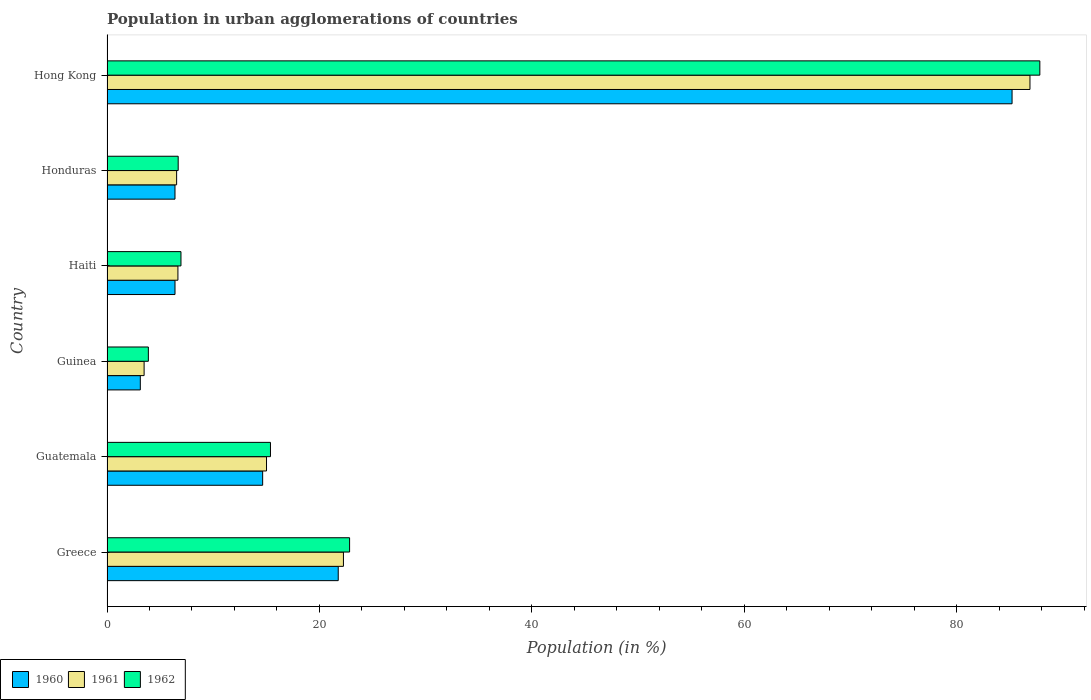How many different coloured bars are there?
Make the answer very short. 3. How many bars are there on the 1st tick from the top?
Give a very brief answer. 3. How many bars are there on the 6th tick from the bottom?
Offer a very short reply. 3. What is the label of the 3rd group of bars from the top?
Ensure brevity in your answer.  Haiti. In how many cases, is the number of bars for a given country not equal to the number of legend labels?
Your answer should be compact. 0. What is the percentage of population in urban agglomerations in 1960 in Guinea?
Make the answer very short. 3.14. Across all countries, what is the maximum percentage of population in urban agglomerations in 1960?
Make the answer very short. 85.2. Across all countries, what is the minimum percentage of population in urban agglomerations in 1962?
Your answer should be compact. 3.89. In which country was the percentage of population in urban agglomerations in 1962 maximum?
Your response must be concise. Hong Kong. In which country was the percentage of population in urban agglomerations in 1960 minimum?
Provide a succinct answer. Guinea. What is the total percentage of population in urban agglomerations in 1961 in the graph?
Provide a short and direct response. 140.89. What is the difference between the percentage of population in urban agglomerations in 1960 in Greece and that in Hong Kong?
Offer a very short reply. -63.44. What is the difference between the percentage of population in urban agglomerations in 1961 in Honduras and the percentage of population in urban agglomerations in 1962 in Guinea?
Provide a succinct answer. 2.66. What is the average percentage of population in urban agglomerations in 1960 per country?
Your response must be concise. 22.93. What is the difference between the percentage of population in urban agglomerations in 1960 and percentage of population in urban agglomerations in 1962 in Haiti?
Your answer should be very brief. -0.56. What is the ratio of the percentage of population in urban agglomerations in 1960 in Guinea to that in Honduras?
Make the answer very short. 0.49. Is the percentage of population in urban agglomerations in 1960 in Guatemala less than that in Honduras?
Your response must be concise. No. Is the difference between the percentage of population in urban agglomerations in 1960 in Guinea and Haiti greater than the difference between the percentage of population in urban agglomerations in 1962 in Guinea and Haiti?
Provide a succinct answer. No. What is the difference between the highest and the second highest percentage of population in urban agglomerations in 1962?
Offer a terse response. 64.98. What is the difference between the highest and the lowest percentage of population in urban agglomerations in 1960?
Keep it short and to the point. 82.07. Is the sum of the percentage of population in urban agglomerations in 1962 in Greece and Guatemala greater than the maximum percentage of population in urban agglomerations in 1961 across all countries?
Ensure brevity in your answer.  No. What does the 1st bar from the top in Hong Kong represents?
Give a very brief answer. 1962. What does the 1st bar from the bottom in Guatemala represents?
Your response must be concise. 1960. How many bars are there?
Your answer should be very brief. 18. Are all the bars in the graph horizontal?
Make the answer very short. Yes. What is the difference between two consecutive major ticks on the X-axis?
Offer a terse response. 20. Does the graph contain any zero values?
Give a very brief answer. No. Does the graph contain grids?
Your answer should be compact. No. Where does the legend appear in the graph?
Keep it short and to the point. Bottom left. How many legend labels are there?
Make the answer very short. 3. How are the legend labels stacked?
Ensure brevity in your answer.  Horizontal. What is the title of the graph?
Your answer should be compact. Population in urban agglomerations of countries. Does "1991" appear as one of the legend labels in the graph?
Make the answer very short. No. What is the label or title of the Y-axis?
Your answer should be compact. Country. What is the Population (in %) of 1960 in Greece?
Your answer should be compact. 21.77. What is the Population (in %) in 1961 in Greece?
Keep it short and to the point. 22.26. What is the Population (in %) of 1962 in Greece?
Ensure brevity in your answer.  22.84. What is the Population (in %) of 1960 in Guatemala?
Make the answer very short. 14.65. What is the Population (in %) of 1961 in Guatemala?
Provide a short and direct response. 15.02. What is the Population (in %) of 1962 in Guatemala?
Keep it short and to the point. 15.39. What is the Population (in %) of 1960 in Guinea?
Provide a short and direct response. 3.14. What is the Population (in %) of 1961 in Guinea?
Offer a very short reply. 3.49. What is the Population (in %) of 1962 in Guinea?
Ensure brevity in your answer.  3.89. What is the Population (in %) of 1960 in Haiti?
Give a very brief answer. 6.4. What is the Population (in %) in 1961 in Haiti?
Give a very brief answer. 6.68. What is the Population (in %) in 1962 in Haiti?
Your response must be concise. 6.96. What is the Population (in %) in 1960 in Honduras?
Give a very brief answer. 6.4. What is the Population (in %) of 1961 in Honduras?
Make the answer very short. 6.55. What is the Population (in %) in 1962 in Honduras?
Your answer should be compact. 6.7. What is the Population (in %) in 1960 in Hong Kong?
Provide a short and direct response. 85.2. What is the Population (in %) in 1961 in Hong Kong?
Your answer should be compact. 86.89. What is the Population (in %) in 1962 in Hong Kong?
Give a very brief answer. 87.82. Across all countries, what is the maximum Population (in %) of 1960?
Provide a succinct answer. 85.2. Across all countries, what is the maximum Population (in %) of 1961?
Offer a terse response. 86.89. Across all countries, what is the maximum Population (in %) of 1962?
Provide a short and direct response. 87.82. Across all countries, what is the minimum Population (in %) of 1960?
Offer a terse response. 3.14. Across all countries, what is the minimum Population (in %) of 1961?
Keep it short and to the point. 3.49. Across all countries, what is the minimum Population (in %) of 1962?
Your answer should be compact. 3.89. What is the total Population (in %) in 1960 in the graph?
Provide a short and direct response. 137.56. What is the total Population (in %) of 1961 in the graph?
Your answer should be very brief. 140.89. What is the total Population (in %) of 1962 in the graph?
Your answer should be compact. 143.6. What is the difference between the Population (in %) in 1960 in Greece and that in Guatemala?
Keep it short and to the point. 7.12. What is the difference between the Population (in %) of 1961 in Greece and that in Guatemala?
Your response must be concise. 7.24. What is the difference between the Population (in %) in 1962 in Greece and that in Guatemala?
Offer a very short reply. 7.45. What is the difference between the Population (in %) of 1960 in Greece and that in Guinea?
Give a very brief answer. 18.63. What is the difference between the Population (in %) in 1961 in Greece and that in Guinea?
Your response must be concise. 18.77. What is the difference between the Population (in %) of 1962 in Greece and that in Guinea?
Ensure brevity in your answer.  18.94. What is the difference between the Population (in %) of 1960 in Greece and that in Haiti?
Give a very brief answer. 15.37. What is the difference between the Population (in %) of 1961 in Greece and that in Haiti?
Keep it short and to the point. 15.58. What is the difference between the Population (in %) of 1962 in Greece and that in Haiti?
Offer a very short reply. 15.87. What is the difference between the Population (in %) in 1960 in Greece and that in Honduras?
Your answer should be very brief. 15.37. What is the difference between the Population (in %) of 1961 in Greece and that in Honduras?
Your answer should be very brief. 15.7. What is the difference between the Population (in %) in 1962 in Greece and that in Honduras?
Offer a very short reply. 16.14. What is the difference between the Population (in %) in 1960 in Greece and that in Hong Kong?
Make the answer very short. -63.44. What is the difference between the Population (in %) in 1961 in Greece and that in Hong Kong?
Keep it short and to the point. -64.63. What is the difference between the Population (in %) in 1962 in Greece and that in Hong Kong?
Ensure brevity in your answer.  -64.98. What is the difference between the Population (in %) in 1960 in Guatemala and that in Guinea?
Offer a very short reply. 11.52. What is the difference between the Population (in %) in 1961 in Guatemala and that in Guinea?
Ensure brevity in your answer.  11.52. What is the difference between the Population (in %) of 1962 in Guatemala and that in Guinea?
Your answer should be compact. 11.49. What is the difference between the Population (in %) of 1960 in Guatemala and that in Haiti?
Offer a very short reply. 8.25. What is the difference between the Population (in %) of 1961 in Guatemala and that in Haiti?
Offer a terse response. 8.34. What is the difference between the Population (in %) of 1962 in Guatemala and that in Haiti?
Ensure brevity in your answer.  8.43. What is the difference between the Population (in %) in 1960 in Guatemala and that in Honduras?
Keep it short and to the point. 8.25. What is the difference between the Population (in %) in 1961 in Guatemala and that in Honduras?
Your answer should be very brief. 8.46. What is the difference between the Population (in %) in 1962 in Guatemala and that in Honduras?
Give a very brief answer. 8.69. What is the difference between the Population (in %) in 1960 in Guatemala and that in Hong Kong?
Ensure brevity in your answer.  -70.55. What is the difference between the Population (in %) of 1961 in Guatemala and that in Hong Kong?
Keep it short and to the point. -71.87. What is the difference between the Population (in %) of 1962 in Guatemala and that in Hong Kong?
Make the answer very short. -72.43. What is the difference between the Population (in %) in 1960 in Guinea and that in Haiti?
Make the answer very short. -3.27. What is the difference between the Population (in %) of 1961 in Guinea and that in Haiti?
Offer a very short reply. -3.18. What is the difference between the Population (in %) in 1962 in Guinea and that in Haiti?
Give a very brief answer. -3.07. What is the difference between the Population (in %) of 1960 in Guinea and that in Honduras?
Your answer should be very brief. -3.27. What is the difference between the Population (in %) of 1961 in Guinea and that in Honduras?
Your response must be concise. -3.06. What is the difference between the Population (in %) in 1962 in Guinea and that in Honduras?
Give a very brief answer. -2.81. What is the difference between the Population (in %) of 1960 in Guinea and that in Hong Kong?
Provide a short and direct response. -82.07. What is the difference between the Population (in %) in 1961 in Guinea and that in Hong Kong?
Your answer should be very brief. -83.4. What is the difference between the Population (in %) in 1962 in Guinea and that in Hong Kong?
Provide a short and direct response. -83.93. What is the difference between the Population (in %) of 1960 in Haiti and that in Honduras?
Ensure brevity in your answer.  0. What is the difference between the Population (in %) in 1961 in Haiti and that in Honduras?
Provide a short and direct response. 0.12. What is the difference between the Population (in %) of 1962 in Haiti and that in Honduras?
Provide a short and direct response. 0.26. What is the difference between the Population (in %) in 1960 in Haiti and that in Hong Kong?
Make the answer very short. -78.8. What is the difference between the Population (in %) in 1961 in Haiti and that in Hong Kong?
Ensure brevity in your answer.  -80.21. What is the difference between the Population (in %) of 1962 in Haiti and that in Hong Kong?
Provide a succinct answer. -80.86. What is the difference between the Population (in %) of 1960 in Honduras and that in Hong Kong?
Your answer should be very brief. -78.8. What is the difference between the Population (in %) of 1961 in Honduras and that in Hong Kong?
Your answer should be compact. -80.34. What is the difference between the Population (in %) in 1962 in Honduras and that in Hong Kong?
Your answer should be very brief. -81.12. What is the difference between the Population (in %) of 1960 in Greece and the Population (in %) of 1961 in Guatemala?
Offer a very short reply. 6.75. What is the difference between the Population (in %) in 1960 in Greece and the Population (in %) in 1962 in Guatemala?
Your answer should be very brief. 6.38. What is the difference between the Population (in %) of 1961 in Greece and the Population (in %) of 1962 in Guatemala?
Make the answer very short. 6.87. What is the difference between the Population (in %) of 1960 in Greece and the Population (in %) of 1961 in Guinea?
Give a very brief answer. 18.27. What is the difference between the Population (in %) in 1960 in Greece and the Population (in %) in 1962 in Guinea?
Provide a succinct answer. 17.87. What is the difference between the Population (in %) of 1961 in Greece and the Population (in %) of 1962 in Guinea?
Your answer should be very brief. 18.37. What is the difference between the Population (in %) of 1960 in Greece and the Population (in %) of 1961 in Haiti?
Make the answer very short. 15.09. What is the difference between the Population (in %) in 1960 in Greece and the Population (in %) in 1962 in Haiti?
Keep it short and to the point. 14.81. What is the difference between the Population (in %) in 1961 in Greece and the Population (in %) in 1962 in Haiti?
Provide a succinct answer. 15.3. What is the difference between the Population (in %) of 1960 in Greece and the Population (in %) of 1961 in Honduras?
Your answer should be very brief. 15.21. What is the difference between the Population (in %) in 1960 in Greece and the Population (in %) in 1962 in Honduras?
Your answer should be compact. 15.07. What is the difference between the Population (in %) of 1961 in Greece and the Population (in %) of 1962 in Honduras?
Provide a succinct answer. 15.56. What is the difference between the Population (in %) of 1960 in Greece and the Population (in %) of 1961 in Hong Kong?
Provide a succinct answer. -65.12. What is the difference between the Population (in %) in 1960 in Greece and the Population (in %) in 1962 in Hong Kong?
Make the answer very short. -66.05. What is the difference between the Population (in %) in 1961 in Greece and the Population (in %) in 1962 in Hong Kong?
Your answer should be very brief. -65.56. What is the difference between the Population (in %) of 1960 in Guatemala and the Population (in %) of 1961 in Guinea?
Provide a succinct answer. 11.16. What is the difference between the Population (in %) in 1960 in Guatemala and the Population (in %) in 1962 in Guinea?
Make the answer very short. 10.76. What is the difference between the Population (in %) of 1961 in Guatemala and the Population (in %) of 1962 in Guinea?
Offer a very short reply. 11.12. What is the difference between the Population (in %) of 1960 in Guatemala and the Population (in %) of 1961 in Haiti?
Give a very brief answer. 7.98. What is the difference between the Population (in %) in 1960 in Guatemala and the Population (in %) in 1962 in Haiti?
Provide a short and direct response. 7.69. What is the difference between the Population (in %) in 1961 in Guatemala and the Population (in %) in 1962 in Haiti?
Give a very brief answer. 8.05. What is the difference between the Population (in %) of 1960 in Guatemala and the Population (in %) of 1961 in Honduras?
Provide a short and direct response. 8.1. What is the difference between the Population (in %) in 1960 in Guatemala and the Population (in %) in 1962 in Honduras?
Ensure brevity in your answer.  7.95. What is the difference between the Population (in %) in 1961 in Guatemala and the Population (in %) in 1962 in Honduras?
Offer a very short reply. 8.32. What is the difference between the Population (in %) of 1960 in Guatemala and the Population (in %) of 1961 in Hong Kong?
Ensure brevity in your answer.  -72.24. What is the difference between the Population (in %) of 1960 in Guatemala and the Population (in %) of 1962 in Hong Kong?
Keep it short and to the point. -73.17. What is the difference between the Population (in %) of 1961 in Guatemala and the Population (in %) of 1962 in Hong Kong?
Your answer should be compact. -72.8. What is the difference between the Population (in %) of 1960 in Guinea and the Population (in %) of 1961 in Haiti?
Provide a short and direct response. -3.54. What is the difference between the Population (in %) of 1960 in Guinea and the Population (in %) of 1962 in Haiti?
Provide a succinct answer. -3.83. What is the difference between the Population (in %) of 1961 in Guinea and the Population (in %) of 1962 in Haiti?
Your answer should be compact. -3.47. What is the difference between the Population (in %) of 1960 in Guinea and the Population (in %) of 1961 in Honduras?
Ensure brevity in your answer.  -3.42. What is the difference between the Population (in %) of 1960 in Guinea and the Population (in %) of 1962 in Honduras?
Offer a very short reply. -3.57. What is the difference between the Population (in %) in 1961 in Guinea and the Population (in %) in 1962 in Honduras?
Offer a terse response. -3.21. What is the difference between the Population (in %) of 1960 in Guinea and the Population (in %) of 1961 in Hong Kong?
Ensure brevity in your answer.  -83.75. What is the difference between the Population (in %) of 1960 in Guinea and the Population (in %) of 1962 in Hong Kong?
Provide a short and direct response. -84.68. What is the difference between the Population (in %) of 1961 in Guinea and the Population (in %) of 1962 in Hong Kong?
Your answer should be very brief. -84.33. What is the difference between the Population (in %) in 1960 in Haiti and the Population (in %) in 1961 in Honduras?
Your answer should be very brief. -0.15. What is the difference between the Population (in %) in 1960 in Haiti and the Population (in %) in 1962 in Honduras?
Provide a succinct answer. -0.3. What is the difference between the Population (in %) in 1961 in Haiti and the Population (in %) in 1962 in Honduras?
Offer a terse response. -0.02. What is the difference between the Population (in %) in 1960 in Haiti and the Population (in %) in 1961 in Hong Kong?
Provide a short and direct response. -80.49. What is the difference between the Population (in %) of 1960 in Haiti and the Population (in %) of 1962 in Hong Kong?
Ensure brevity in your answer.  -81.42. What is the difference between the Population (in %) of 1961 in Haiti and the Population (in %) of 1962 in Hong Kong?
Your answer should be compact. -81.14. What is the difference between the Population (in %) of 1960 in Honduras and the Population (in %) of 1961 in Hong Kong?
Offer a very short reply. -80.49. What is the difference between the Population (in %) of 1960 in Honduras and the Population (in %) of 1962 in Hong Kong?
Provide a succinct answer. -81.42. What is the difference between the Population (in %) of 1961 in Honduras and the Population (in %) of 1962 in Hong Kong?
Ensure brevity in your answer.  -81.27. What is the average Population (in %) in 1960 per country?
Make the answer very short. 22.93. What is the average Population (in %) in 1961 per country?
Provide a short and direct response. 23.48. What is the average Population (in %) of 1962 per country?
Provide a succinct answer. 23.93. What is the difference between the Population (in %) in 1960 and Population (in %) in 1961 in Greece?
Offer a terse response. -0.49. What is the difference between the Population (in %) of 1960 and Population (in %) of 1962 in Greece?
Offer a terse response. -1.07. What is the difference between the Population (in %) in 1961 and Population (in %) in 1962 in Greece?
Provide a succinct answer. -0.58. What is the difference between the Population (in %) of 1960 and Population (in %) of 1961 in Guatemala?
Provide a short and direct response. -0.36. What is the difference between the Population (in %) of 1960 and Population (in %) of 1962 in Guatemala?
Your answer should be compact. -0.74. What is the difference between the Population (in %) of 1961 and Population (in %) of 1962 in Guatemala?
Provide a succinct answer. -0.37. What is the difference between the Population (in %) in 1960 and Population (in %) in 1961 in Guinea?
Your answer should be compact. -0.36. What is the difference between the Population (in %) of 1960 and Population (in %) of 1962 in Guinea?
Keep it short and to the point. -0.76. What is the difference between the Population (in %) in 1960 and Population (in %) in 1961 in Haiti?
Provide a succinct answer. -0.27. What is the difference between the Population (in %) in 1960 and Population (in %) in 1962 in Haiti?
Provide a short and direct response. -0.56. What is the difference between the Population (in %) in 1961 and Population (in %) in 1962 in Haiti?
Keep it short and to the point. -0.29. What is the difference between the Population (in %) in 1960 and Population (in %) in 1961 in Honduras?
Your response must be concise. -0.15. What is the difference between the Population (in %) in 1960 and Population (in %) in 1962 in Honduras?
Keep it short and to the point. -0.3. What is the difference between the Population (in %) of 1961 and Population (in %) of 1962 in Honduras?
Provide a succinct answer. -0.15. What is the difference between the Population (in %) of 1960 and Population (in %) of 1961 in Hong Kong?
Your answer should be very brief. -1.69. What is the difference between the Population (in %) of 1960 and Population (in %) of 1962 in Hong Kong?
Make the answer very short. -2.62. What is the difference between the Population (in %) of 1961 and Population (in %) of 1962 in Hong Kong?
Your response must be concise. -0.93. What is the ratio of the Population (in %) in 1960 in Greece to that in Guatemala?
Offer a very short reply. 1.49. What is the ratio of the Population (in %) in 1961 in Greece to that in Guatemala?
Your answer should be compact. 1.48. What is the ratio of the Population (in %) of 1962 in Greece to that in Guatemala?
Keep it short and to the point. 1.48. What is the ratio of the Population (in %) in 1960 in Greece to that in Guinea?
Make the answer very short. 6.94. What is the ratio of the Population (in %) in 1961 in Greece to that in Guinea?
Offer a terse response. 6.37. What is the ratio of the Population (in %) of 1962 in Greece to that in Guinea?
Your answer should be very brief. 5.87. What is the ratio of the Population (in %) in 1960 in Greece to that in Haiti?
Give a very brief answer. 3.4. What is the ratio of the Population (in %) in 1961 in Greece to that in Haiti?
Offer a terse response. 3.33. What is the ratio of the Population (in %) of 1962 in Greece to that in Haiti?
Ensure brevity in your answer.  3.28. What is the ratio of the Population (in %) in 1960 in Greece to that in Honduras?
Your answer should be compact. 3.4. What is the ratio of the Population (in %) of 1961 in Greece to that in Honduras?
Offer a very short reply. 3.4. What is the ratio of the Population (in %) in 1962 in Greece to that in Honduras?
Keep it short and to the point. 3.41. What is the ratio of the Population (in %) of 1960 in Greece to that in Hong Kong?
Offer a very short reply. 0.26. What is the ratio of the Population (in %) of 1961 in Greece to that in Hong Kong?
Offer a very short reply. 0.26. What is the ratio of the Population (in %) in 1962 in Greece to that in Hong Kong?
Offer a very short reply. 0.26. What is the ratio of the Population (in %) in 1960 in Guatemala to that in Guinea?
Offer a very short reply. 4.67. What is the ratio of the Population (in %) in 1961 in Guatemala to that in Guinea?
Keep it short and to the point. 4.3. What is the ratio of the Population (in %) in 1962 in Guatemala to that in Guinea?
Provide a short and direct response. 3.95. What is the ratio of the Population (in %) in 1960 in Guatemala to that in Haiti?
Give a very brief answer. 2.29. What is the ratio of the Population (in %) of 1961 in Guatemala to that in Haiti?
Offer a terse response. 2.25. What is the ratio of the Population (in %) in 1962 in Guatemala to that in Haiti?
Your response must be concise. 2.21. What is the ratio of the Population (in %) of 1960 in Guatemala to that in Honduras?
Your response must be concise. 2.29. What is the ratio of the Population (in %) in 1961 in Guatemala to that in Honduras?
Offer a very short reply. 2.29. What is the ratio of the Population (in %) of 1962 in Guatemala to that in Honduras?
Offer a terse response. 2.3. What is the ratio of the Population (in %) of 1960 in Guatemala to that in Hong Kong?
Offer a very short reply. 0.17. What is the ratio of the Population (in %) in 1961 in Guatemala to that in Hong Kong?
Your answer should be compact. 0.17. What is the ratio of the Population (in %) of 1962 in Guatemala to that in Hong Kong?
Ensure brevity in your answer.  0.18. What is the ratio of the Population (in %) of 1960 in Guinea to that in Haiti?
Keep it short and to the point. 0.49. What is the ratio of the Population (in %) of 1961 in Guinea to that in Haiti?
Your answer should be compact. 0.52. What is the ratio of the Population (in %) in 1962 in Guinea to that in Haiti?
Ensure brevity in your answer.  0.56. What is the ratio of the Population (in %) of 1960 in Guinea to that in Honduras?
Provide a succinct answer. 0.49. What is the ratio of the Population (in %) in 1961 in Guinea to that in Honduras?
Provide a short and direct response. 0.53. What is the ratio of the Population (in %) in 1962 in Guinea to that in Honduras?
Provide a succinct answer. 0.58. What is the ratio of the Population (in %) in 1960 in Guinea to that in Hong Kong?
Offer a very short reply. 0.04. What is the ratio of the Population (in %) in 1961 in Guinea to that in Hong Kong?
Your answer should be compact. 0.04. What is the ratio of the Population (in %) of 1962 in Guinea to that in Hong Kong?
Your response must be concise. 0.04. What is the ratio of the Population (in %) of 1960 in Haiti to that in Honduras?
Keep it short and to the point. 1. What is the ratio of the Population (in %) of 1961 in Haiti to that in Honduras?
Your response must be concise. 1.02. What is the ratio of the Population (in %) of 1962 in Haiti to that in Honduras?
Make the answer very short. 1.04. What is the ratio of the Population (in %) of 1960 in Haiti to that in Hong Kong?
Ensure brevity in your answer.  0.08. What is the ratio of the Population (in %) of 1961 in Haiti to that in Hong Kong?
Give a very brief answer. 0.08. What is the ratio of the Population (in %) of 1962 in Haiti to that in Hong Kong?
Give a very brief answer. 0.08. What is the ratio of the Population (in %) of 1960 in Honduras to that in Hong Kong?
Provide a short and direct response. 0.08. What is the ratio of the Population (in %) of 1961 in Honduras to that in Hong Kong?
Keep it short and to the point. 0.08. What is the ratio of the Population (in %) in 1962 in Honduras to that in Hong Kong?
Ensure brevity in your answer.  0.08. What is the difference between the highest and the second highest Population (in %) in 1960?
Give a very brief answer. 63.44. What is the difference between the highest and the second highest Population (in %) in 1961?
Your response must be concise. 64.63. What is the difference between the highest and the second highest Population (in %) of 1962?
Offer a very short reply. 64.98. What is the difference between the highest and the lowest Population (in %) in 1960?
Make the answer very short. 82.07. What is the difference between the highest and the lowest Population (in %) of 1961?
Offer a terse response. 83.4. What is the difference between the highest and the lowest Population (in %) in 1962?
Offer a very short reply. 83.93. 